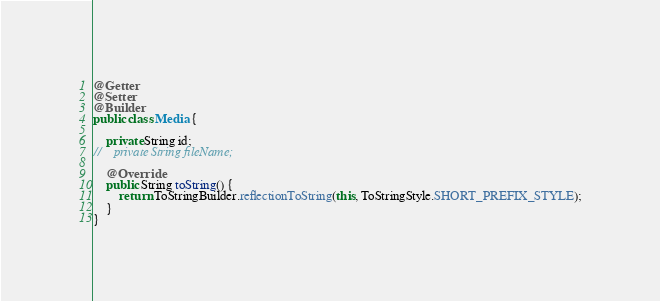<code> <loc_0><loc_0><loc_500><loc_500><_Java_>@Getter
@Setter
@Builder
public class Media {

    private String id;
//    private String fileName;

    @Override
    public String toString() {
        return ToStringBuilder.reflectionToString(this, ToStringStyle.SHORT_PREFIX_STYLE);
    }
}
</code> 